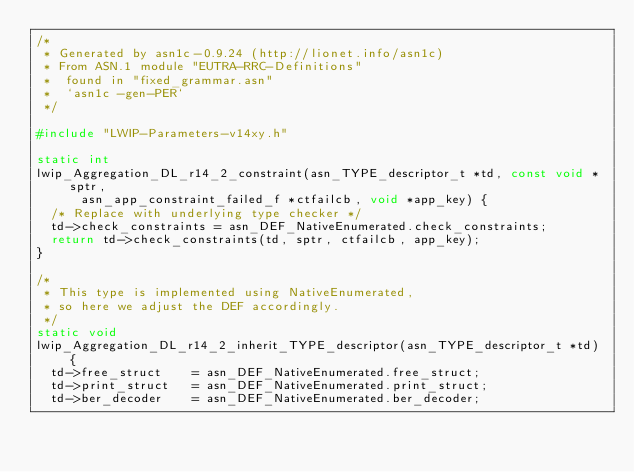Convert code to text. <code><loc_0><loc_0><loc_500><loc_500><_C_>/*
 * Generated by asn1c-0.9.24 (http://lionet.info/asn1c)
 * From ASN.1 module "EUTRA-RRC-Definitions"
 * 	found in "fixed_grammar.asn"
 * 	`asn1c -gen-PER`
 */

#include "LWIP-Parameters-v14xy.h"

static int
lwip_Aggregation_DL_r14_2_constraint(asn_TYPE_descriptor_t *td, const void *sptr,
			asn_app_constraint_failed_f *ctfailcb, void *app_key) {
	/* Replace with underlying type checker */
	td->check_constraints = asn_DEF_NativeEnumerated.check_constraints;
	return td->check_constraints(td, sptr, ctfailcb, app_key);
}

/*
 * This type is implemented using NativeEnumerated,
 * so here we adjust the DEF accordingly.
 */
static void
lwip_Aggregation_DL_r14_2_inherit_TYPE_descriptor(asn_TYPE_descriptor_t *td) {
	td->free_struct    = asn_DEF_NativeEnumerated.free_struct;
	td->print_struct   = asn_DEF_NativeEnumerated.print_struct;
	td->ber_decoder    = asn_DEF_NativeEnumerated.ber_decoder;</code> 